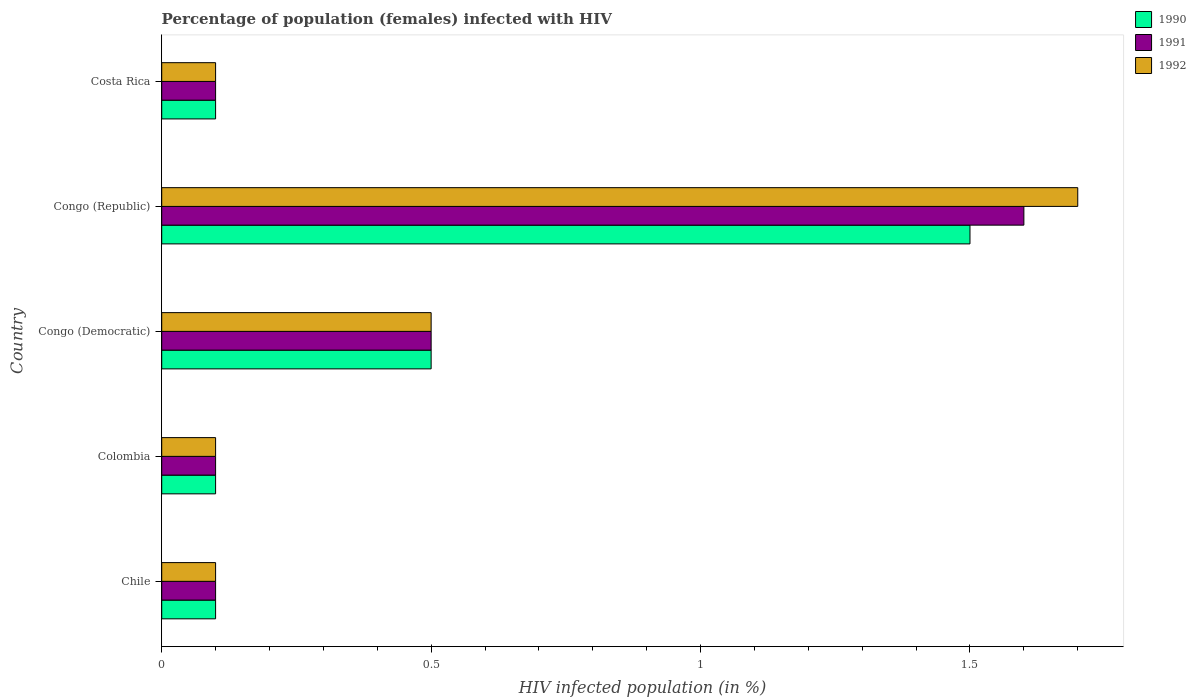How many groups of bars are there?
Keep it short and to the point. 5. How many bars are there on the 4th tick from the bottom?
Offer a very short reply. 3. What is the label of the 1st group of bars from the top?
Ensure brevity in your answer.  Costa Rica. In how many cases, is the number of bars for a given country not equal to the number of legend labels?
Make the answer very short. 0. Across all countries, what is the minimum percentage of HIV infected female population in 1992?
Make the answer very short. 0.1. In which country was the percentage of HIV infected female population in 1991 maximum?
Provide a short and direct response. Congo (Republic). What is the total percentage of HIV infected female population in 1990 in the graph?
Your response must be concise. 2.3. What is the average percentage of HIV infected female population in 1992 per country?
Ensure brevity in your answer.  0.5. In how many countries, is the percentage of HIV infected female population in 1991 greater than 1.6 %?
Ensure brevity in your answer.  0. What is the ratio of the percentage of HIV infected female population in 1990 in Chile to that in Congo (Democratic)?
Your answer should be very brief. 0.2. Is the percentage of HIV infected female population in 1990 in Chile less than that in Colombia?
Offer a very short reply. No. Is the difference between the percentage of HIV infected female population in 1992 in Congo (Republic) and Costa Rica greater than the difference between the percentage of HIV infected female population in 1990 in Congo (Republic) and Costa Rica?
Offer a terse response. Yes. Is the sum of the percentage of HIV infected female population in 1991 in Chile and Congo (Democratic) greater than the maximum percentage of HIV infected female population in 1992 across all countries?
Your response must be concise. No. What does the 3rd bar from the bottom in Congo (Democratic) represents?
Your response must be concise. 1992. How many bars are there?
Your answer should be compact. 15. How many countries are there in the graph?
Provide a short and direct response. 5. Are the values on the major ticks of X-axis written in scientific E-notation?
Your response must be concise. No. Where does the legend appear in the graph?
Your answer should be compact. Top right. How many legend labels are there?
Your answer should be very brief. 3. How are the legend labels stacked?
Provide a succinct answer. Vertical. What is the title of the graph?
Ensure brevity in your answer.  Percentage of population (females) infected with HIV. Does "2007" appear as one of the legend labels in the graph?
Ensure brevity in your answer.  No. What is the label or title of the X-axis?
Your response must be concise. HIV infected population (in %). What is the label or title of the Y-axis?
Offer a terse response. Country. What is the HIV infected population (in %) of 1990 in Chile?
Provide a short and direct response. 0.1. What is the HIV infected population (in %) of 1992 in Chile?
Your answer should be very brief. 0.1. What is the HIV infected population (in %) of 1991 in Colombia?
Keep it short and to the point. 0.1. What is the HIV infected population (in %) in 1992 in Colombia?
Offer a very short reply. 0.1. What is the HIV infected population (in %) in 1990 in Congo (Democratic)?
Your response must be concise. 0.5. What is the HIV infected population (in %) in 1991 in Congo (Democratic)?
Keep it short and to the point. 0.5. What is the HIV infected population (in %) of 1990 in Congo (Republic)?
Provide a succinct answer. 1.5. What is the HIV infected population (in %) in 1991 in Congo (Republic)?
Provide a short and direct response. 1.6. What is the HIV infected population (in %) of 1991 in Costa Rica?
Provide a succinct answer. 0.1. Across all countries, what is the maximum HIV infected population (in %) of 1990?
Offer a terse response. 1.5. Across all countries, what is the maximum HIV infected population (in %) of 1991?
Ensure brevity in your answer.  1.6. Across all countries, what is the maximum HIV infected population (in %) in 1992?
Your response must be concise. 1.7. Across all countries, what is the minimum HIV infected population (in %) in 1990?
Offer a very short reply. 0.1. Across all countries, what is the minimum HIV infected population (in %) of 1991?
Give a very brief answer. 0.1. Across all countries, what is the minimum HIV infected population (in %) in 1992?
Your answer should be very brief. 0.1. What is the total HIV infected population (in %) in 1990 in the graph?
Give a very brief answer. 2.3. What is the total HIV infected population (in %) in 1992 in the graph?
Provide a short and direct response. 2.5. What is the difference between the HIV infected population (in %) in 1990 in Chile and that in Colombia?
Offer a terse response. 0. What is the difference between the HIV infected population (in %) of 1991 in Chile and that in Colombia?
Your answer should be compact. 0. What is the difference between the HIV infected population (in %) in 1992 in Chile and that in Colombia?
Provide a succinct answer. 0. What is the difference between the HIV infected population (in %) in 1991 in Chile and that in Congo (Democratic)?
Provide a succinct answer. -0.4. What is the difference between the HIV infected population (in %) of 1992 in Chile and that in Congo (Democratic)?
Offer a terse response. -0.4. What is the difference between the HIV infected population (in %) of 1992 in Chile and that in Costa Rica?
Ensure brevity in your answer.  0. What is the difference between the HIV infected population (in %) of 1991 in Colombia and that in Congo (Democratic)?
Offer a very short reply. -0.4. What is the difference between the HIV infected population (in %) of 1992 in Colombia and that in Congo (Democratic)?
Your response must be concise. -0.4. What is the difference between the HIV infected population (in %) in 1990 in Colombia and that in Costa Rica?
Your response must be concise. 0. What is the difference between the HIV infected population (in %) of 1992 in Colombia and that in Costa Rica?
Provide a short and direct response. 0. What is the difference between the HIV infected population (in %) of 1990 in Congo (Democratic) and that in Congo (Republic)?
Offer a very short reply. -1. What is the difference between the HIV infected population (in %) in 1991 in Congo (Democratic) and that in Congo (Republic)?
Make the answer very short. -1.1. What is the difference between the HIV infected population (in %) in 1992 in Congo (Democratic) and that in Congo (Republic)?
Give a very brief answer. -1.2. What is the difference between the HIV infected population (in %) of 1991 in Congo (Republic) and that in Costa Rica?
Ensure brevity in your answer.  1.5. What is the difference between the HIV infected population (in %) in 1990 in Chile and the HIV infected population (in %) in 1992 in Colombia?
Your response must be concise. 0. What is the difference between the HIV infected population (in %) in 1990 in Chile and the HIV infected population (in %) in 1991 in Costa Rica?
Provide a short and direct response. 0. What is the difference between the HIV infected population (in %) in 1990 in Colombia and the HIV infected population (in %) in 1991 in Congo (Democratic)?
Give a very brief answer. -0.4. What is the difference between the HIV infected population (in %) of 1991 in Colombia and the HIV infected population (in %) of 1992 in Congo (Democratic)?
Offer a very short reply. -0.4. What is the difference between the HIV infected population (in %) of 1990 in Colombia and the HIV infected population (in %) of 1991 in Congo (Republic)?
Provide a short and direct response. -1.5. What is the difference between the HIV infected population (in %) in 1991 in Colombia and the HIV infected population (in %) in 1992 in Congo (Republic)?
Your response must be concise. -1.6. What is the difference between the HIV infected population (in %) of 1990 in Colombia and the HIV infected population (in %) of 1992 in Costa Rica?
Make the answer very short. 0. What is the difference between the HIV infected population (in %) in 1991 in Colombia and the HIV infected population (in %) in 1992 in Costa Rica?
Your answer should be very brief. 0. What is the difference between the HIV infected population (in %) of 1991 in Congo (Democratic) and the HIV infected population (in %) of 1992 in Congo (Republic)?
Your response must be concise. -1.2. What is the difference between the HIV infected population (in %) of 1990 in Congo (Democratic) and the HIV infected population (in %) of 1991 in Costa Rica?
Keep it short and to the point. 0.4. What is the difference between the HIV infected population (in %) in 1990 in Congo (Democratic) and the HIV infected population (in %) in 1992 in Costa Rica?
Ensure brevity in your answer.  0.4. What is the difference between the HIV infected population (in %) of 1990 in Congo (Republic) and the HIV infected population (in %) of 1991 in Costa Rica?
Provide a short and direct response. 1.4. What is the average HIV infected population (in %) in 1990 per country?
Offer a terse response. 0.46. What is the average HIV infected population (in %) in 1991 per country?
Your response must be concise. 0.48. What is the difference between the HIV infected population (in %) in 1990 and HIV infected population (in %) in 1991 in Chile?
Offer a terse response. 0. What is the difference between the HIV infected population (in %) in 1990 and HIV infected population (in %) in 1992 in Chile?
Your answer should be compact. 0. What is the difference between the HIV infected population (in %) of 1991 and HIV infected population (in %) of 1992 in Chile?
Make the answer very short. 0. What is the difference between the HIV infected population (in %) in 1991 and HIV infected population (in %) in 1992 in Colombia?
Offer a terse response. 0. What is the difference between the HIV infected population (in %) of 1990 and HIV infected population (in %) of 1991 in Congo (Republic)?
Your answer should be compact. -0.1. What is the difference between the HIV infected population (in %) of 1990 and HIV infected population (in %) of 1992 in Congo (Republic)?
Offer a very short reply. -0.2. What is the difference between the HIV infected population (in %) of 1990 and HIV infected population (in %) of 1991 in Costa Rica?
Give a very brief answer. 0. What is the difference between the HIV infected population (in %) of 1990 and HIV infected population (in %) of 1992 in Costa Rica?
Your answer should be very brief. 0. What is the difference between the HIV infected population (in %) in 1991 and HIV infected population (in %) in 1992 in Costa Rica?
Your answer should be compact. 0. What is the ratio of the HIV infected population (in %) of 1991 in Chile to that in Colombia?
Give a very brief answer. 1. What is the ratio of the HIV infected population (in %) in 1992 in Chile to that in Congo (Democratic)?
Your response must be concise. 0.2. What is the ratio of the HIV infected population (in %) of 1990 in Chile to that in Congo (Republic)?
Your answer should be very brief. 0.07. What is the ratio of the HIV infected population (in %) in 1991 in Chile to that in Congo (Republic)?
Your answer should be compact. 0.06. What is the ratio of the HIV infected population (in %) of 1992 in Chile to that in Congo (Republic)?
Offer a very short reply. 0.06. What is the ratio of the HIV infected population (in %) in 1990 in Chile to that in Costa Rica?
Provide a short and direct response. 1. What is the ratio of the HIV infected population (in %) of 1991 in Chile to that in Costa Rica?
Provide a short and direct response. 1. What is the ratio of the HIV infected population (in %) in 1992 in Chile to that in Costa Rica?
Your answer should be very brief. 1. What is the ratio of the HIV infected population (in %) in 1990 in Colombia to that in Congo (Democratic)?
Provide a short and direct response. 0.2. What is the ratio of the HIV infected population (in %) in 1991 in Colombia to that in Congo (Democratic)?
Offer a terse response. 0.2. What is the ratio of the HIV infected population (in %) of 1992 in Colombia to that in Congo (Democratic)?
Your answer should be very brief. 0.2. What is the ratio of the HIV infected population (in %) of 1990 in Colombia to that in Congo (Republic)?
Ensure brevity in your answer.  0.07. What is the ratio of the HIV infected population (in %) in 1991 in Colombia to that in Congo (Republic)?
Your response must be concise. 0.06. What is the ratio of the HIV infected population (in %) in 1992 in Colombia to that in Congo (Republic)?
Provide a succinct answer. 0.06. What is the ratio of the HIV infected population (in %) of 1990 in Colombia to that in Costa Rica?
Give a very brief answer. 1. What is the ratio of the HIV infected population (in %) of 1991 in Colombia to that in Costa Rica?
Ensure brevity in your answer.  1. What is the ratio of the HIV infected population (in %) in 1992 in Colombia to that in Costa Rica?
Ensure brevity in your answer.  1. What is the ratio of the HIV infected population (in %) of 1990 in Congo (Democratic) to that in Congo (Republic)?
Your answer should be compact. 0.33. What is the ratio of the HIV infected population (in %) in 1991 in Congo (Democratic) to that in Congo (Republic)?
Your answer should be very brief. 0.31. What is the ratio of the HIV infected population (in %) of 1992 in Congo (Democratic) to that in Congo (Republic)?
Your answer should be compact. 0.29. What is the ratio of the HIV infected population (in %) of 1990 in Congo (Republic) to that in Costa Rica?
Your answer should be very brief. 15. What is the difference between the highest and the second highest HIV infected population (in %) in 1990?
Your response must be concise. 1. What is the difference between the highest and the second highest HIV infected population (in %) of 1992?
Offer a very short reply. 1.2. What is the difference between the highest and the lowest HIV infected population (in %) in 1990?
Offer a terse response. 1.4. What is the difference between the highest and the lowest HIV infected population (in %) of 1992?
Provide a succinct answer. 1.6. 